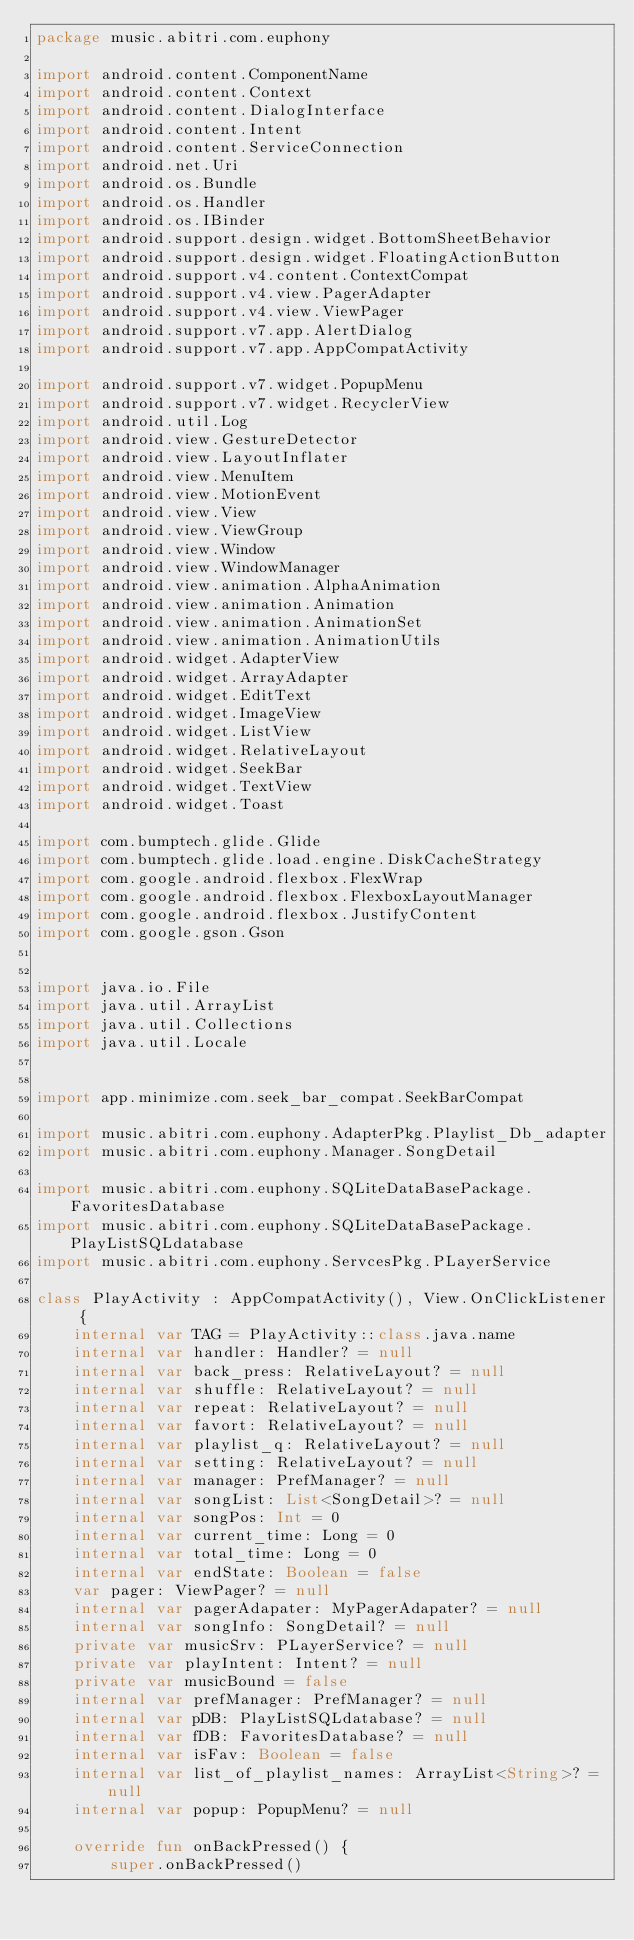<code> <loc_0><loc_0><loc_500><loc_500><_Kotlin_>package music.abitri.com.euphony

import android.content.ComponentName
import android.content.Context
import android.content.DialogInterface
import android.content.Intent
import android.content.ServiceConnection
import android.net.Uri
import android.os.Bundle
import android.os.Handler
import android.os.IBinder
import android.support.design.widget.BottomSheetBehavior
import android.support.design.widget.FloatingActionButton
import android.support.v4.content.ContextCompat
import android.support.v4.view.PagerAdapter
import android.support.v4.view.ViewPager
import android.support.v7.app.AlertDialog
import android.support.v7.app.AppCompatActivity

import android.support.v7.widget.PopupMenu
import android.support.v7.widget.RecyclerView
import android.util.Log
import android.view.GestureDetector
import android.view.LayoutInflater
import android.view.MenuItem
import android.view.MotionEvent
import android.view.View
import android.view.ViewGroup
import android.view.Window
import android.view.WindowManager
import android.view.animation.AlphaAnimation
import android.view.animation.Animation
import android.view.animation.AnimationSet
import android.view.animation.AnimationUtils
import android.widget.AdapterView
import android.widget.ArrayAdapter
import android.widget.EditText
import android.widget.ImageView
import android.widget.ListView
import android.widget.RelativeLayout
import android.widget.SeekBar
import android.widget.TextView
import android.widget.Toast

import com.bumptech.glide.Glide
import com.bumptech.glide.load.engine.DiskCacheStrategy
import com.google.android.flexbox.FlexWrap
import com.google.android.flexbox.FlexboxLayoutManager
import com.google.android.flexbox.JustifyContent
import com.google.gson.Gson


import java.io.File
import java.util.ArrayList
import java.util.Collections
import java.util.Locale


import app.minimize.com.seek_bar_compat.SeekBarCompat

import music.abitri.com.euphony.AdapterPkg.Playlist_Db_adapter
import music.abitri.com.euphony.Manager.SongDetail

import music.abitri.com.euphony.SQLiteDataBasePackage.FavoritesDatabase
import music.abitri.com.euphony.SQLiteDataBasePackage.PlayListSQLdatabase
import music.abitri.com.euphony.ServcesPkg.PLayerService

class PlayActivity : AppCompatActivity(), View.OnClickListener {
    internal var TAG = PlayActivity::class.java.name
    internal var handler: Handler? = null
    internal var back_press: RelativeLayout? = null
    internal var shuffle: RelativeLayout? = null
    internal var repeat: RelativeLayout? = null
    internal var favort: RelativeLayout? = null
    internal var playlist_q: RelativeLayout? = null
    internal var setting: RelativeLayout? = null
    internal var manager: PrefManager? = null
    internal var songList: List<SongDetail>? = null
    internal var songPos: Int = 0
    internal var current_time: Long = 0
    internal var total_time: Long = 0
    internal var endState: Boolean = false
    var pager: ViewPager? = null
    internal var pagerAdapater: MyPagerAdapater? = null
    internal var songInfo: SongDetail? = null
    private var musicSrv: PLayerService? = null
    private var playIntent: Intent? = null
    private var musicBound = false
    internal var prefManager: PrefManager? = null
    internal var pDB: PlayListSQLdatabase? = null
    internal var fDB: FavoritesDatabase? = null
    internal var isFav: Boolean = false
    internal var list_of_playlist_names: ArrayList<String>? = null
    internal var popup: PopupMenu? = null

    override fun onBackPressed() {
        super.onBackPressed()</code> 